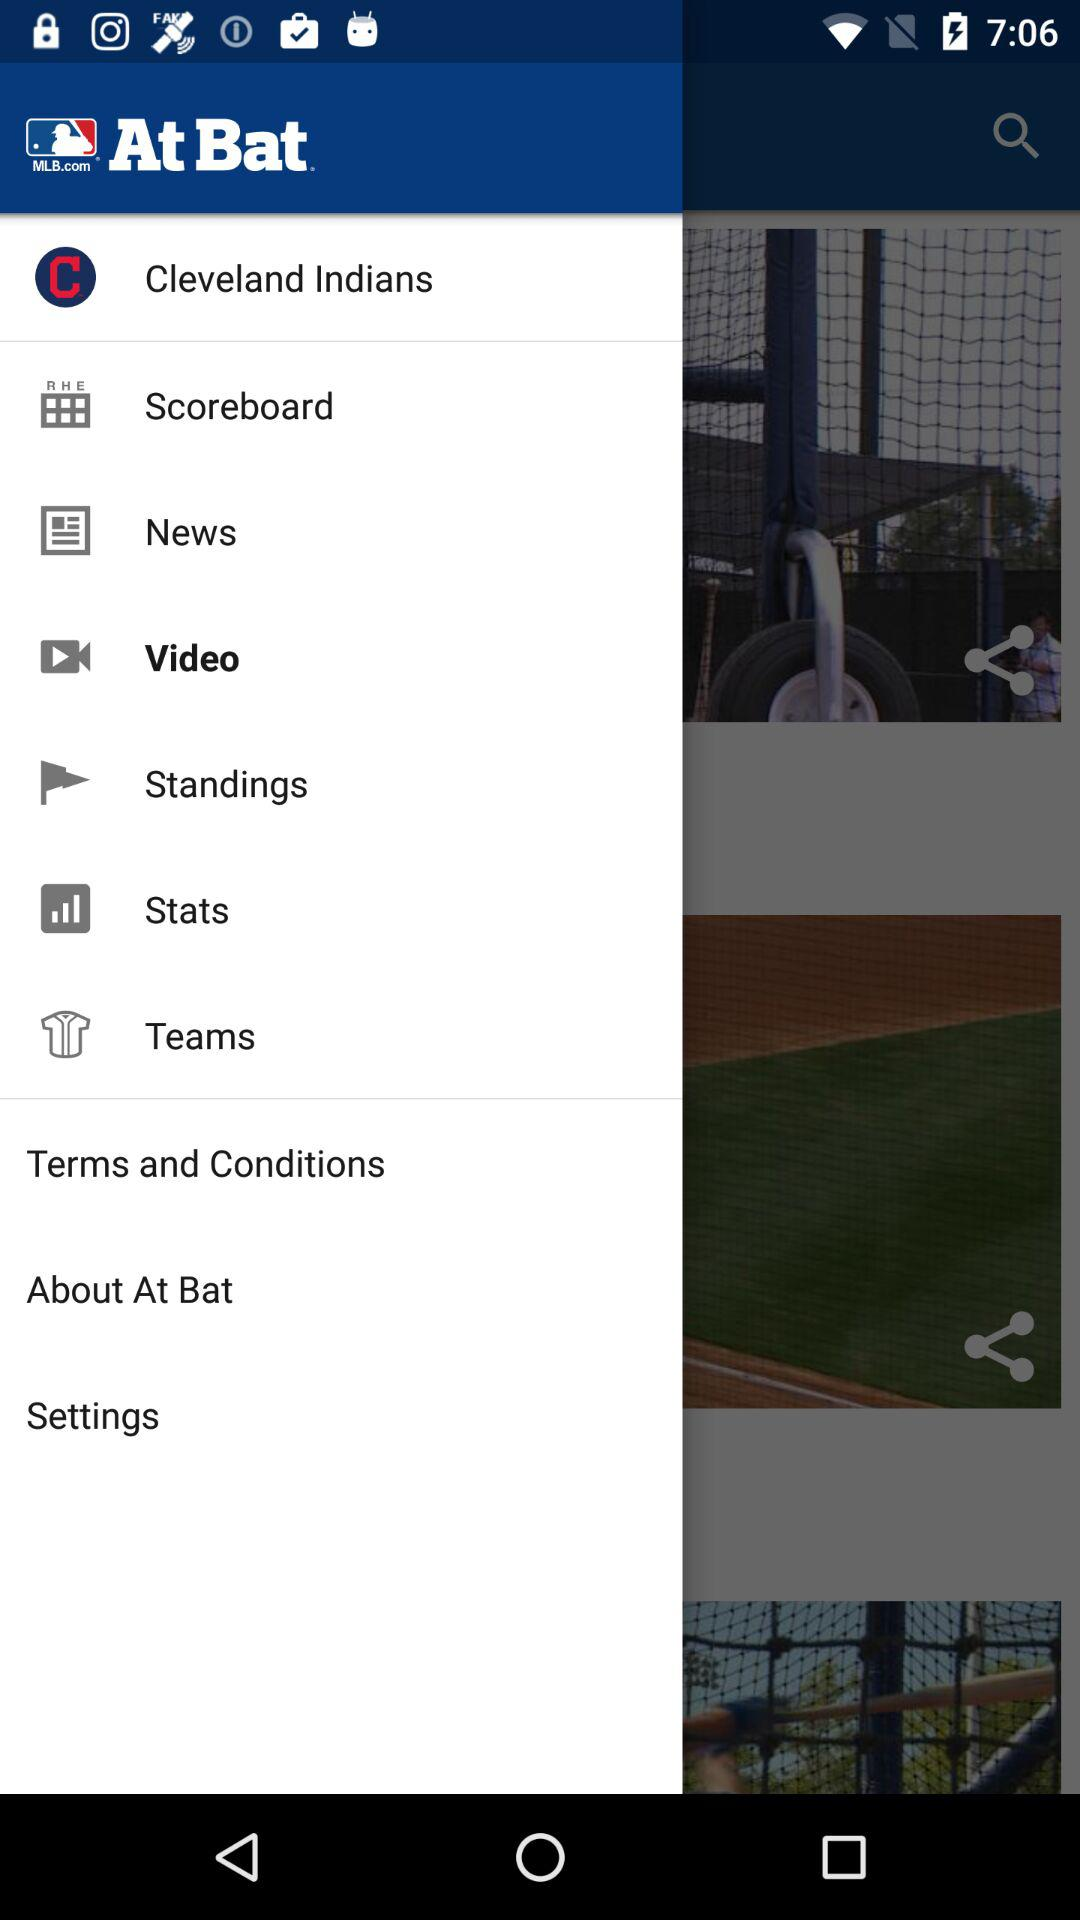What is the team name? The team name is the "Cleveland Indians". 